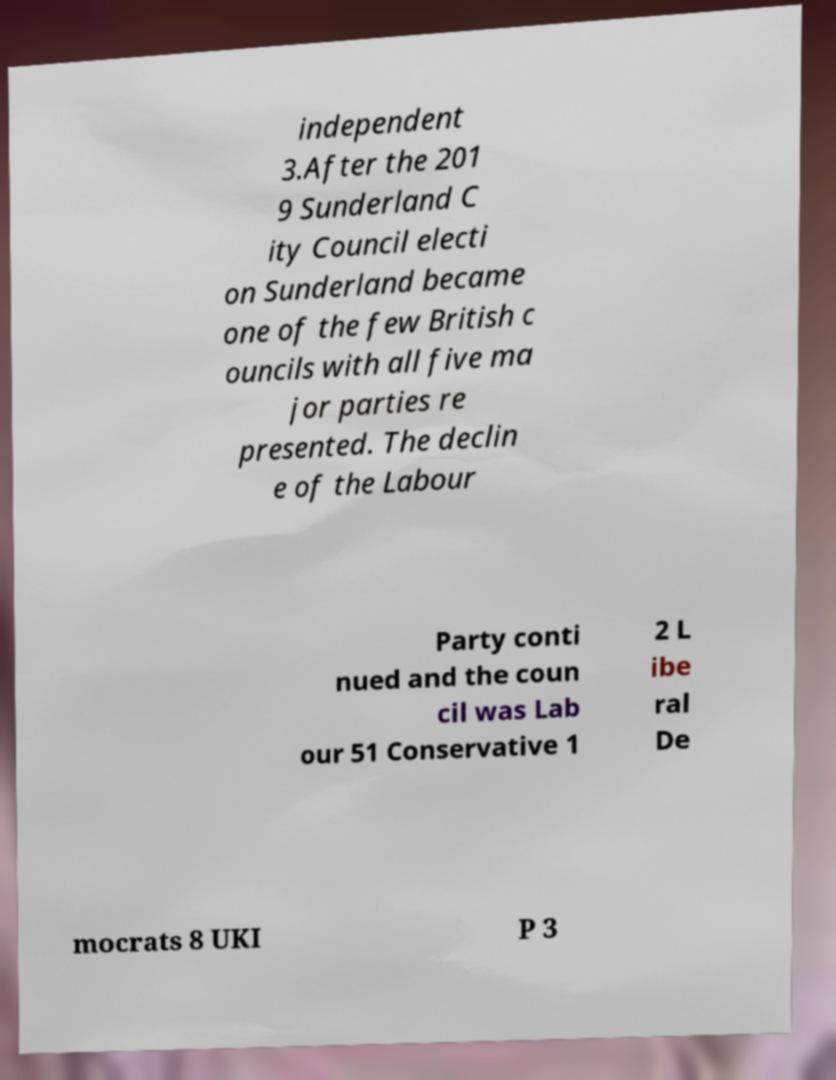Could you extract and type out the text from this image? independent 3.After the 201 9 Sunderland C ity Council electi on Sunderland became one of the few British c ouncils with all five ma jor parties re presented. The declin e of the Labour Party conti nued and the coun cil was Lab our 51 Conservative 1 2 L ibe ral De mocrats 8 UKI P 3 